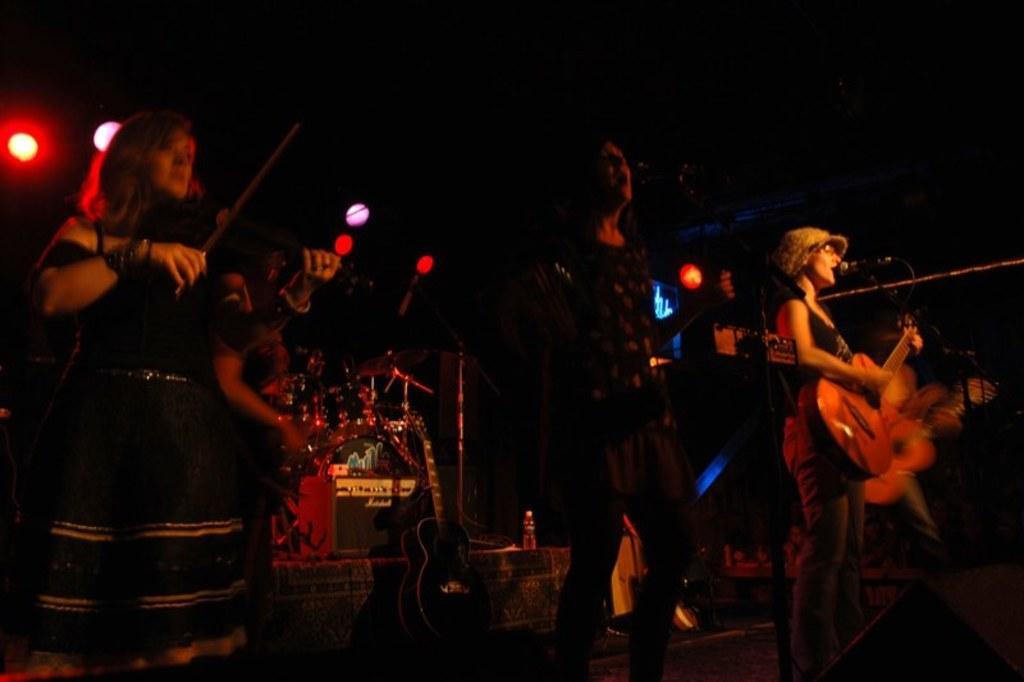In one or two sentences, can you explain what this image depicts? In the image there is orchestra on the stage and there are lights over the ceiling. 